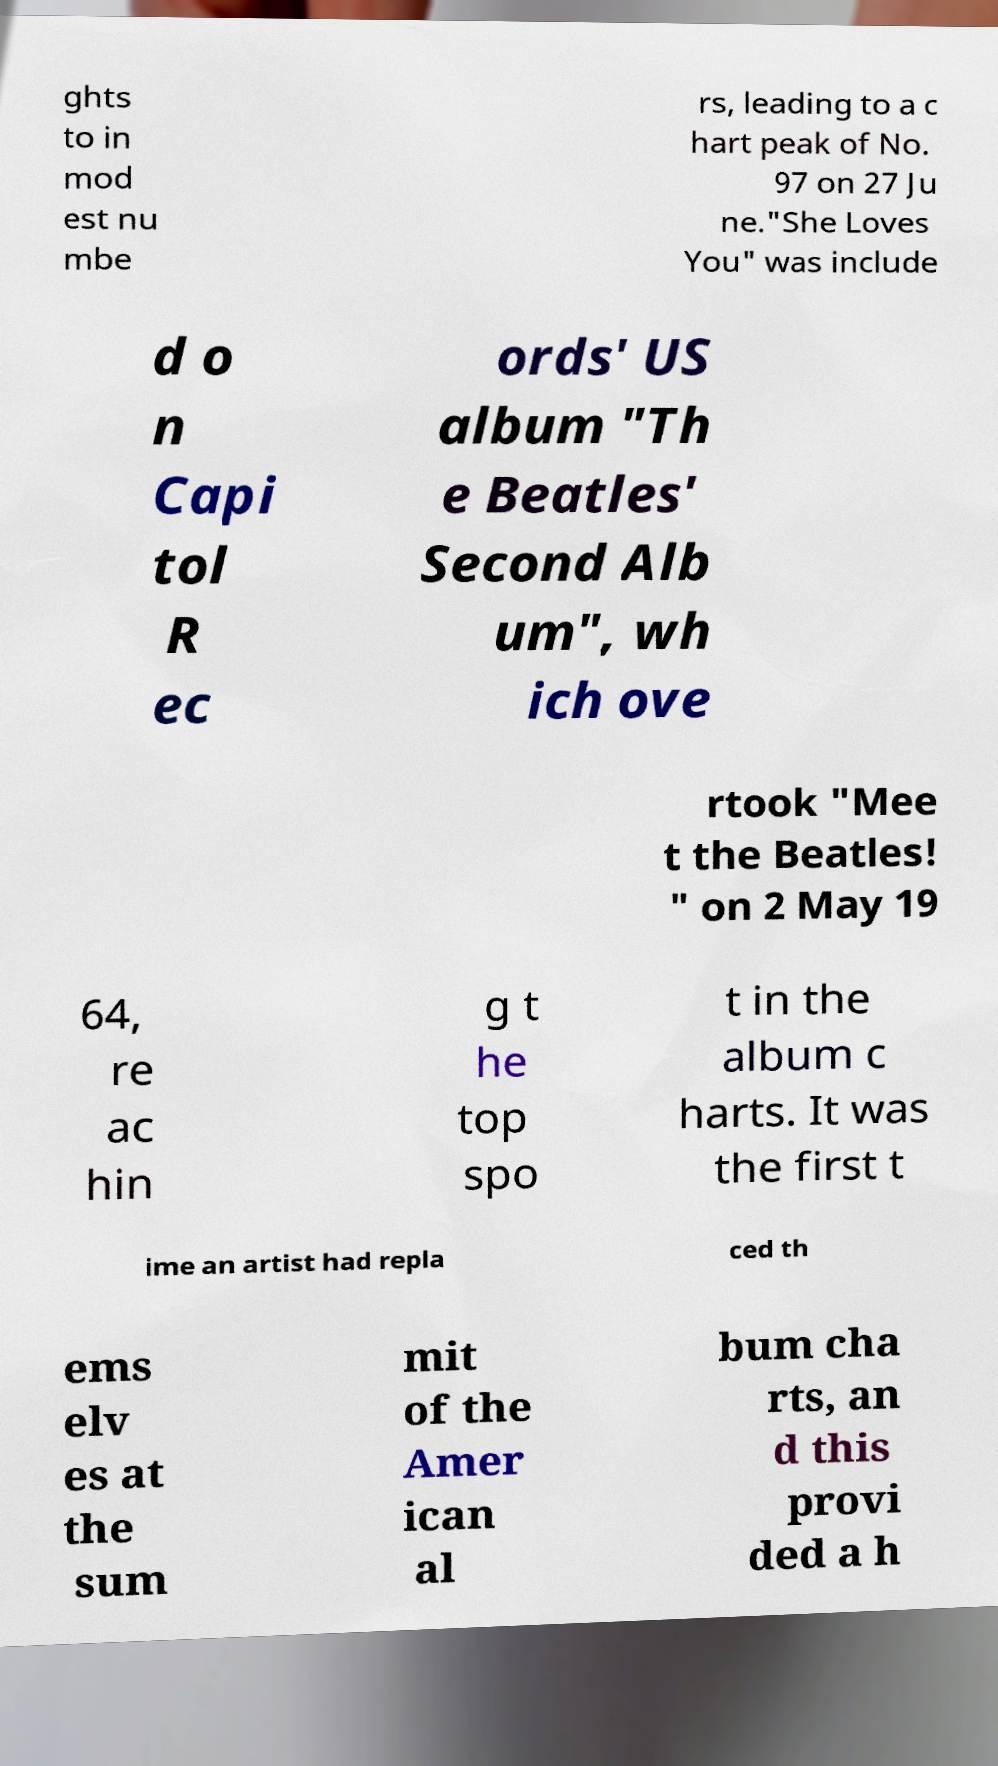For documentation purposes, I need the text within this image transcribed. Could you provide that? ghts to in mod est nu mbe rs, leading to a c hart peak of No. 97 on 27 Ju ne."She Loves You" was include d o n Capi tol R ec ords' US album "Th e Beatles' Second Alb um", wh ich ove rtook "Mee t the Beatles! " on 2 May 19 64, re ac hin g t he top spo t in the album c harts. It was the first t ime an artist had repla ced th ems elv es at the sum mit of the Amer ican al bum cha rts, an d this provi ded a h 